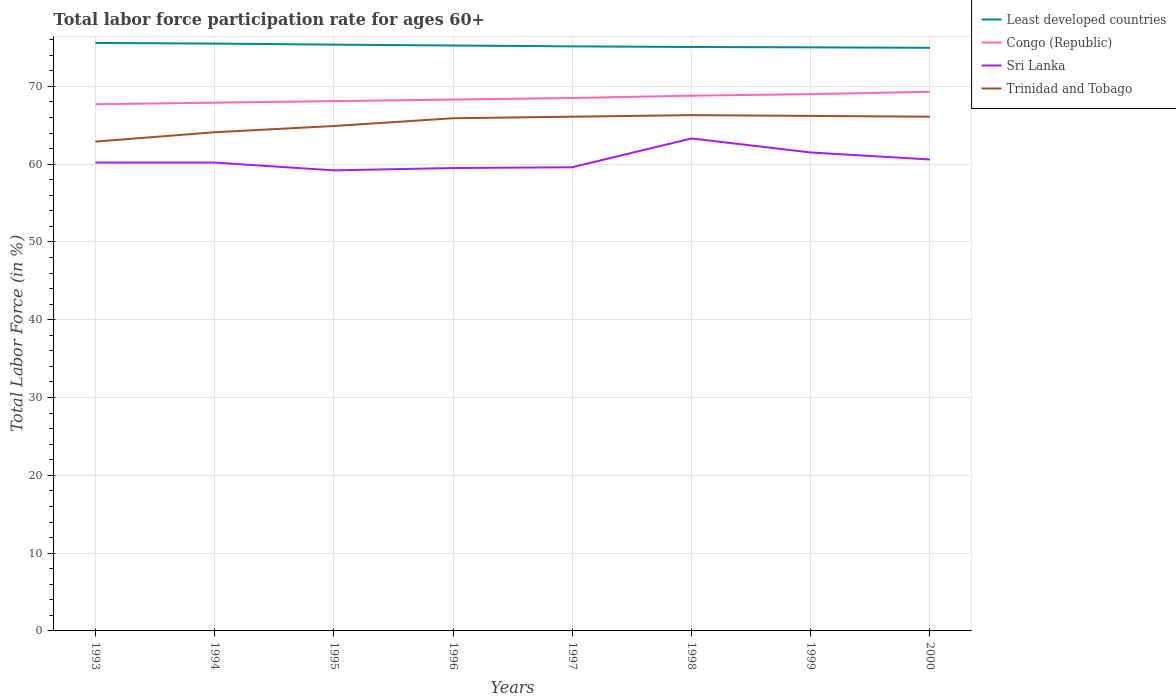How many different coloured lines are there?
Provide a succinct answer. 4. Does the line corresponding to Least developed countries intersect with the line corresponding to Sri Lanka?
Keep it short and to the point. No. Across all years, what is the maximum labor force participation rate in Least developed countries?
Provide a short and direct response. 74.95. In which year was the labor force participation rate in Sri Lanka maximum?
Provide a succinct answer. 1995. What is the total labor force participation rate in Least developed countries in the graph?
Ensure brevity in your answer.  0.11. What is the difference between the highest and the second highest labor force participation rate in Least developed countries?
Offer a terse response. 0.62. How many years are there in the graph?
Ensure brevity in your answer.  8. Are the values on the major ticks of Y-axis written in scientific E-notation?
Keep it short and to the point. No. Does the graph contain any zero values?
Your response must be concise. No. How many legend labels are there?
Provide a succinct answer. 4. What is the title of the graph?
Give a very brief answer. Total labor force participation rate for ages 60+. Does "Kiribati" appear as one of the legend labels in the graph?
Provide a succinct answer. No. What is the Total Labor Force (in %) in Least developed countries in 1993?
Keep it short and to the point. 75.58. What is the Total Labor Force (in %) of Congo (Republic) in 1993?
Your response must be concise. 67.7. What is the Total Labor Force (in %) of Sri Lanka in 1993?
Ensure brevity in your answer.  60.2. What is the Total Labor Force (in %) in Trinidad and Tobago in 1993?
Ensure brevity in your answer.  62.9. What is the Total Labor Force (in %) of Least developed countries in 1994?
Provide a short and direct response. 75.49. What is the Total Labor Force (in %) of Congo (Republic) in 1994?
Offer a terse response. 67.9. What is the Total Labor Force (in %) in Sri Lanka in 1994?
Make the answer very short. 60.2. What is the Total Labor Force (in %) in Trinidad and Tobago in 1994?
Your answer should be very brief. 64.1. What is the Total Labor Force (in %) in Least developed countries in 1995?
Keep it short and to the point. 75.36. What is the Total Labor Force (in %) of Congo (Republic) in 1995?
Make the answer very short. 68.1. What is the Total Labor Force (in %) of Sri Lanka in 1995?
Offer a very short reply. 59.2. What is the Total Labor Force (in %) of Trinidad and Tobago in 1995?
Give a very brief answer. 64.9. What is the Total Labor Force (in %) in Least developed countries in 1996?
Your answer should be compact. 75.25. What is the Total Labor Force (in %) of Congo (Republic) in 1996?
Provide a short and direct response. 68.3. What is the Total Labor Force (in %) of Sri Lanka in 1996?
Your answer should be compact. 59.5. What is the Total Labor Force (in %) in Trinidad and Tobago in 1996?
Make the answer very short. 65.9. What is the Total Labor Force (in %) of Least developed countries in 1997?
Your answer should be compact. 75.14. What is the Total Labor Force (in %) in Congo (Republic) in 1997?
Your answer should be very brief. 68.5. What is the Total Labor Force (in %) in Sri Lanka in 1997?
Provide a short and direct response. 59.6. What is the Total Labor Force (in %) in Trinidad and Tobago in 1997?
Your response must be concise. 66.1. What is the Total Labor Force (in %) of Least developed countries in 1998?
Your answer should be very brief. 75.06. What is the Total Labor Force (in %) of Congo (Republic) in 1998?
Provide a short and direct response. 68.8. What is the Total Labor Force (in %) in Sri Lanka in 1998?
Your answer should be compact. 63.3. What is the Total Labor Force (in %) of Trinidad and Tobago in 1998?
Your response must be concise. 66.3. What is the Total Labor Force (in %) in Least developed countries in 1999?
Keep it short and to the point. 75.02. What is the Total Labor Force (in %) of Sri Lanka in 1999?
Provide a succinct answer. 61.5. What is the Total Labor Force (in %) of Trinidad and Tobago in 1999?
Provide a short and direct response. 66.2. What is the Total Labor Force (in %) of Least developed countries in 2000?
Your answer should be compact. 74.95. What is the Total Labor Force (in %) of Congo (Republic) in 2000?
Provide a short and direct response. 69.3. What is the Total Labor Force (in %) of Sri Lanka in 2000?
Your answer should be compact. 60.6. What is the Total Labor Force (in %) of Trinidad and Tobago in 2000?
Provide a short and direct response. 66.1. Across all years, what is the maximum Total Labor Force (in %) in Least developed countries?
Provide a succinct answer. 75.58. Across all years, what is the maximum Total Labor Force (in %) in Congo (Republic)?
Provide a short and direct response. 69.3. Across all years, what is the maximum Total Labor Force (in %) in Sri Lanka?
Keep it short and to the point. 63.3. Across all years, what is the maximum Total Labor Force (in %) of Trinidad and Tobago?
Your response must be concise. 66.3. Across all years, what is the minimum Total Labor Force (in %) of Least developed countries?
Ensure brevity in your answer.  74.95. Across all years, what is the minimum Total Labor Force (in %) in Congo (Republic)?
Ensure brevity in your answer.  67.7. Across all years, what is the minimum Total Labor Force (in %) of Sri Lanka?
Your answer should be very brief. 59.2. Across all years, what is the minimum Total Labor Force (in %) in Trinidad and Tobago?
Your answer should be compact. 62.9. What is the total Total Labor Force (in %) of Least developed countries in the graph?
Offer a terse response. 601.85. What is the total Total Labor Force (in %) of Congo (Republic) in the graph?
Keep it short and to the point. 547.6. What is the total Total Labor Force (in %) in Sri Lanka in the graph?
Your response must be concise. 484.1. What is the total Total Labor Force (in %) in Trinidad and Tobago in the graph?
Offer a terse response. 522.5. What is the difference between the Total Labor Force (in %) in Least developed countries in 1993 and that in 1994?
Provide a short and direct response. 0.08. What is the difference between the Total Labor Force (in %) in Sri Lanka in 1993 and that in 1994?
Make the answer very short. 0. What is the difference between the Total Labor Force (in %) in Trinidad and Tobago in 1993 and that in 1994?
Give a very brief answer. -1.2. What is the difference between the Total Labor Force (in %) of Least developed countries in 1993 and that in 1995?
Provide a short and direct response. 0.22. What is the difference between the Total Labor Force (in %) in Congo (Republic) in 1993 and that in 1995?
Provide a short and direct response. -0.4. What is the difference between the Total Labor Force (in %) in Trinidad and Tobago in 1993 and that in 1995?
Your answer should be compact. -2. What is the difference between the Total Labor Force (in %) in Least developed countries in 1993 and that in 1996?
Your response must be concise. 0.33. What is the difference between the Total Labor Force (in %) of Least developed countries in 1993 and that in 1997?
Keep it short and to the point. 0.44. What is the difference between the Total Labor Force (in %) in Sri Lanka in 1993 and that in 1997?
Your response must be concise. 0.6. What is the difference between the Total Labor Force (in %) of Trinidad and Tobago in 1993 and that in 1997?
Your answer should be very brief. -3.2. What is the difference between the Total Labor Force (in %) of Least developed countries in 1993 and that in 1998?
Ensure brevity in your answer.  0.52. What is the difference between the Total Labor Force (in %) in Sri Lanka in 1993 and that in 1998?
Offer a terse response. -3.1. What is the difference between the Total Labor Force (in %) in Least developed countries in 1993 and that in 1999?
Keep it short and to the point. 0.56. What is the difference between the Total Labor Force (in %) of Congo (Republic) in 1993 and that in 1999?
Your response must be concise. -1.3. What is the difference between the Total Labor Force (in %) of Least developed countries in 1993 and that in 2000?
Keep it short and to the point. 0.62. What is the difference between the Total Labor Force (in %) in Sri Lanka in 1993 and that in 2000?
Your answer should be very brief. -0.4. What is the difference between the Total Labor Force (in %) in Least developed countries in 1994 and that in 1995?
Offer a very short reply. 0.13. What is the difference between the Total Labor Force (in %) in Congo (Republic) in 1994 and that in 1995?
Offer a very short reply. -0.2. What is the difference between the Total Labor Force (in %) in Trinidad and Tobago in 1994 and that in 1995?
Provide a succinct answer. -0.8. What is the difference between the Total Labor Force (in %) of Least developed countries in 1994 and that in 1996?
Offer a very short reply. 0.25. What is the difference between the Total Labor Force (in %) in Sri Lanka in 1994 and that in 1996?
Provide a succinct answer. 0.7. What is the difference between the Total Labor Force (in %) in Trinidad and Tobago in 1994 and that in 1996?
Give a very brief answer. -1.8. What is the difference between the Total Labor Force (in %) in Least developed countries in 1994 and that in 1997?
Offer a very short reply. 0.35. What is the difference between the Total Labor Force (in %) in Least developed countries in 1994 and that in 1998?
Ensure brevity in your answer.  0.44. What is the difference between the Total Labor Force (in %) of Congo (Republic) in 1994 and that in 1998?
Give a very brief answer. -0.9. What is the difference between the Total Labor Force (in %) of Sri Lanka in 1994 and that in 1998?
Offer a terse response. -3.1. What is the difference between the Total Labor Force (in %) of Trinidad and Tobago in 1994 and that in 1998?
Make the answer very short. -2.2. What is the difference between the Total Labor Force (in %) of Least developed countries in 1994 and that in 1999?
Offer a very short reply. 0.48. What is the difference between the Total Labor Force (in %) in Congo (Republic) in 1994 and that in 1999?
Offer a very short reply. -1.1. What is the difference between the Total Labor Force (in %) of Sri Lanka in 1994 and that in 1999?
Offer a terse response. -1.3. What is the difference between the Total Labor Force (in %) in Least developed countries in 1994 and that in 2000?
Ensure brevity in your answer.  0.54. What is the difference between the Total Labor Force (in %) in Sri Lanka in 1994 and that in 2000?
Keep it short and to the point. -0.4. What is the difference between the Total Labor Force (in %) in Trinidad and Tobago in 1994 and that in 2000?
Ensure brevity in your answer.  -2. What is the difference between the Total Labor Force (in %) of Least developed countries in 1995 and that in 1996?
Offer a very short reply. 0.11. What is the difference between the Total Labor Force (in %) of Least developed countries in 1995 and that in 1997?
Make the answer very short. 0.22. What is the difference between the Total Labor Force (in %) in Sri Lanka in 1995 and that in 1997?
Your response must be concise. -0.4. What is the difference between the Total Labor Force (in %) of Trinidad and Tobago in 1995 and that in 1997?
Make the answer very short. -1.2. What is the difference between the Total Labor Force (in %) in Least developed countries in 1995 and that in 1998?
Provide a short and direct response. 0.31. What is the difference between the Total Labor Force (in %) in Congo (Republic) in 1995 and that in 1998?
Your answer should be very brief. -0.7. What is the difference between the Total Labor Force (in %) in Sri Lanka in 1995 and that in 1998?
Give a very brief answer. -4.1. What is the difference between the Total Labor Force (in %) in Least developed countries in 1995 and that in 1999?
Ensure brevity in your answer.  0.35. What is the difference between the Total Labor Force (in %) in Sri Lanka in 1995 and that in 1999?
Your answer should be very brief. -2.3. What is the difference between the Total Labor Force (in %) of Least developed countries in 1995 and that in 2000?
Provide a short and direct response. 0.41. What is the difference between the Total Labor Force (in %) of Sri Lanka in 1995 and that in 2000?
Provide a short and direct response. -1.4. What is the difference between the Total Labor Force (in %) of Trinidad and Tobago in 1995 and that in 2000?
Give a very brief answer. -1.2. What is the difference between the Total Labor Force (in %) in Least developed countries in 1996 and that in 1997?
Keep it short and to the point. 0.11. What is the difference between the Total Labor Force (in %) of Sri Lanka in 1996 and that in 1997?
Your answer should be very brief. -0.1. What is the difference between the Total Labor Force (in %) in Trinidad and Tobago in 1996 and that in 1997?
Ensure brevity in your answer.  -0.2. What is the difference between the Total Labor Force (in %) of Least developed countries in 1996 and that in 1998?
Your answer should be compact. 0.19. What is the difference between the Total Labor Force (in %) in Trinidad and Tobago in 1996 and that in 1998?
Offer a terse response. -0.4. What is the difference between the Total Labor Force (in %) in Least developed countries in 1996 and that in 1999?
Offer a very short reply. 0.23. What is the difference between the Total Labor Force (in %) in Congo (Republic) in 1996 and that in 1999?
Your answer should be very brief. -0.7. What is the difference between the Total Labor Force (in %) of Sri Lanka in 1996 and that in 1999?
Offer a terse response. -2. What is the difference between the Total Labor Force (in %) of Least developed countries in 1996 and that in 2000?
Your response must be concise. 0.29. What is the difference between the Total Labor Force (in %) of Congo (Republic) in 1996 and that in 2000?
Provide a short and direct response. -1. What is the difference between the Total Labor Force (in %) in Trinidad and Tobago in 1996 and that in 2000?
Give a very brief answer. -0.2. What is the difference between the Total Labor Force (in %) in Least developed countries in 1997 and that in 1998?
Your answer should be compact. 0.08. What is the difference between the Total Labor Force (in %) of Sri Lanka in 1997 and that in 1998?
Give a very brief answer. -3.7. What is the difference between the Total Labor Force (in %) of Least developed countries in 1997 and that in 1999?
Offer a terse response. 0.12. What is the difference between the Total Labor Force (in %) in Congo (Republic) in 1997 and that in 1999?
Provide a short and direct response. -0.5. What is the difference between the Total Labor Force (in %) of Least developed countries in 1997 and that in 2000?
Provide a succinct answer. 0.19. What is the difference between the Total Labor Force (in %) of Congo (Republic) in 1997 and that in 2000?
Keep it short and to the point. -0.8. What is the difference between the Total Labor Force (in %) in Sri Lanka in 1997 and that in 2000?
Your answer should be compact. -1. What is the difference between the Total Labor Force (in %) of Trinidad and Tobago in 1997 and that in 2000?
Provide a short and direct response. 0. What is the difference between the Total Labor Force (in %) in Least developed countries in 1998 and that in 1999?
Give a very brief answer. 0.04. What is the difference between the Total Labor Force (in %) of Trinidad and Tobago in 1998 and that in 1999?
Ensure brevity in your answer.  0.1. What is the difference between the Total Labor Force (in %) of Least developed countries in 1998 and that in 2000?
Your response must be concise. 0.1. What is the difference between the Total Labor Force (in %) of Congo (Republic) in 1998 and that in 2000?
Your answer should be very brief. -0.5. What is the difference between the Total Labor Force (in %) in Least developed countries in 1999 and that in 2000?
Your response must be concise. 0.06. What is the difference between the Total Labor Force (in %) in Congo (Republic) in 1999 and that in 2000?
Ensure brevity in your answer.  -0.3. What is the difference between the Total Labor Force (in %) in Sri Lanka in 1999 and that in 2000?
Keep it short and to the point. 0.9. What is the difference between the Total Labor Force (in %) of Trinidad and Tobago in 1999 and that in 2000?
Offer a terse response. 0.1. What is the difference between the Total Labor Force (in %) of Least developed countries in 1993 and the Total Labor Force (in %) of Congo (Republic) in 1994?
Your answer should be very brief. 7.68. What is the difference between the Total Labor Force (in %) of Least developed countries in 1993 and the Total Labor Force (in %) of Sri Lanka in 1994?
Your response must be concise. 15.38. What is the difference between the Total Labor Force (in %) of Least developed countries in 1993 and the Total Labor Force (in %) of Trinidad and Tobago in 1994?
Ensure brevity in your answer.  11.48. What is the difference between the Total Labor Force (in %) in Congo (Republic) in 1993 and the Total Labor Force (in %) in Trinidad and Tobago in 1994?
Your answer should be compact. 3.6. What is the difference between the Total Labor Force (in %) of Least developed countries in 1993 and the Total Labor Force (in %) of Congo (Republic) in 1995?
Your answer should be very brief. 7.48. What is the difference between the Total Labor Force (in %) in Least developed countries in 1993 and the Total Labor Force (in %) in Sri Lanka in 1995?
Provide a succinct answer. 16.38. What is the difference between the Total Labor Force (in %) of Least developed countries in 1993 and the Total Labor Force (in %) of Trinidad and Tobago in 1995?
Your answer should be very brief. 10.68. What is the difference between the Total Labor Force (in %) in Congo (Republic) in 1993 and the Total Labor Force (in %) in Sri Lanka in 1995?
Offer a very short reply. 8.5. What is the difference between the Total Labor Force (in %) of Sri Lanka in 1993 and the Total Labor Force (in %) of Trinidad and Tobago in 1995?
Ensure brevity in your answer.  -4.7. What is the difference between the Total Labor Force (in %) in Least developed countries in 1993 and the Total Labor Force (in %) in Congo (Republic) in 1996?
Your answer should be very brief. 7.28. What is the difference between the Total Labor Force (in %) in Least developed countries in 1993 and the Total Labor Force (in %) in Sri Lanka in 1996?
Your answer should be very brief. 16.08. What is the difference between the Total Labor Force (in %) in Least developed countries in 1993 and the Total Labor Force (in %) in Trinidad and Tobago in 1996?
Ensure brevity in your answer.  9.68. What is the difference between the Total Labor Force (in %) of Congo (Republic) in 1993 and the Total Labor Force (in %) of Sri Lanka in 1996?
Keep it short and to the point. 8.2. What is the difference between the Total Labor Force (in %) of Sri Lanka in 1993 and the Total Labor Force (in %) of Trinidad and Tobago in 1996?
Keep it short and to the point. -5.7. What is the difference between the Total Labor Force (in %) in Least developed countries in 1993 and the Total Labor Force (in %) in Congo (Republic) in 1997?
Offer a terse response. 7.08. What is the difference between the Total Labor Force (in %) in Least developed countries in 1993 and the Total Labor Force (in %) in Sri Lanka in 1997?
Your answer should be very brief. 15.98. What is the difference between the Total Labor Force (in %) of Least developed countries in 1993 and the Total Labor Force (in %) of Trinidad and Tobago in 1997?
Keep it short and to the point. 9.48. What is the difference between the Total Labor Force (in %) in Congo (Republic) in 1993 and the Total Labor Force (in %) in Trinidad and Tobago in 1997?
Ensure brevity in your answer.  1.6. What is the difference between the Total Labor Force (in %) of Sri Lanka in 1993 and the Total Labor Force (in %) of Trinidad and Tobago in 1997?
Provide a short and direct response. -5.9. What is the difference between the Total Labor Force (in %) in Least developed countries in 1993 and the Total Labor Force (in %) in Congo (Republic) in 1998?
Provide a succinct answer. 6.78. What is the difference between the Total Labor Force (in %) of Least developed countries in 1993 and the Total Labor Force (in %) of Sri Lanka in 1998?
Keep it short and to the point. 12.28. What is the difference between the Total Labor Force (in %) of Least developed countries in 1993 and the Total Labor Force (in %) of Trinidad and Tobago in 1998?
Provide a short and direct response. 9.28. What is the difference between the Total Labor Force (in %) in Congo (Republic) in 1993 and the Total Labor Force (in %) in Sri Lanka in 1998?
Provide a succinct answer. 4.4. What is the difference between the Total Labor Force (in %) of Least developed countries in 1993 and the Total Labor Force (in %) of Congo (Republic) in 1999?
Make the answer very short. 6.58. What is the difference between the Total Labor Force (in %) of Least developed countries in 1993 and the Total Labor Force (in %) of Sri Lanka in 1999?
Provide a short and direct response. 14.08. What is the difference between the Total Labor Force (in %) in Least developed countries in 1993 and the Total Labor Force (in %) in Trinidad and Tobago in 1999?
Give a very brief answer. 9.38. What is the difference between the Total Labor Force (in %) of Sri Lanka in 1993 and the Total Labor Force (in %) of Trinidad and Tobago in 1999?
Your answer should be very brief. -6. What is the difference between the Total Labor Force (in %) in Least developed countries in 1993 and the Total Labor Force (in %) in Congo (Republic) in 2000?
Give a very brief answer. 6.28. What is the difference between the Total Labor Force (in %) of Least developed countries in 1993 and the Total Labor Force (in %) of Sri Lanka in 2000?
Give a very brief answer. 14.98. What is the difference between the Total Labor Force (in %) in Least developed countries in 1993 and the Total Labor Force (in %) in Trinidad and Tobago in 2000?
Your answer should be compact. 9.48. What is the difference between the Total Labor Force (in %) in Sri Lanka in 1993 and the Total Labor Force (in %) in Trinidad and Tobago in 2000?
Make the answer very short. -5.9. What is the difference between the Total Labor Force (in %) of Least developed countries in 1994 and the Total Labor Force (in %) of Congo (Republic) in 1995?
Provide a short and direct response. 7.39. What is the difference between the Total Labor Force (in %) in Least developed countries in 1994 and the Total Labor Force (in %) in Sri Lanka in 1995?
Offer a very short reply. 16.29. What is the difference between the Total Labor Force (in %) of Least developed countries in 1994 and the Total Labor Force (in %) of Trinidad and Tobago in 1995?
Provide a short and direct response. 10.59. What is the difference between the Total Labor Force (in %) of Congo (Republic) in 1994 and the Total Labor Force (in %) of Sri Lanka in 1995?
Provide a short and direct response. 8.7. What is the difference between the Total Labor Force (in %) of Least developed countries in 1994 and the Total Labor Force (in %) of Congo (Republic) in 1996?
Give a very brief answer. 7.19. What is the difference between the Total Labor Force (in %) of Least developed countries in 1994 and the Total Labor Force (in %) of Sri Lanka in 1996?
Ensure brevity in your answer.  15.99. What is the difference between the Total Labor Force (in %) of Least developed countries in 1994 and the Total Labor Force (in %) of Trinidad and Tobago in 1996?
Your answer should be very brief. 9.59. What is the difference between the Total Labor Force (in %) in Congo (Republic) in 1994 and the Total Labor Force (in %) in Trinidad and Tobago in 1996?
Your answer should be compact. 2. What is the difference between the Total Labor Force (in %) in Sri Lanka in 1994 and the Total Labor Force (in %) in Trinidad and Tobago in 1996?
Offer a very short reply. -5.7. What is the difference between the Total Labor Force (in %) of Least developed countries in 1994 and the Total Labor Force (in %) of Congo (Republic) in 1997?
Your answer should be very brief. 6.99. What is the difference between the Total Labor Force (in %) in Least developed countries in 1994 and the Total Labor Force (in %) in Sri Lanka in 1997?
Provide a short and direct response. 15.89. What is the difference between the Total Labor Force (in %) in Least developed countries in 1994 and the Total Labor Force (in %) in Trinidad and Tobago in 1997?
Offer a very short reply. 9.39. What is the difference between the Total Labor Force (in %) of Congo (Republic) in 1994 and the Total Labor Force (in %) of Sri Lanka in 1997?
Offer a very short reply. 8.3. What is the difference between the Total Labor Force (in %) in Congo (Republic) in 1994 and the Total Labor Force (in %) in Trinidad and Tobago in 1997?
Offer a terse response. 1.8. What is the difference between the Total Labor Force (in %) of Least developed countries in 1994 and the Total Labor Force (in %) of Congo (Republic) in 1998?
Give a very brief answer. 6.69. What is the difference between the Total Labor Force (in %) of Least developed countries in 1994 and the Total Labor Force (in %) of Sri Lanka in 1998?
Your answer should be very brief. 12.19. What is the difference between the Total Labor Force (in %) of Least developed countries in 1994 and the Total Labor Force (in %) of Trinidad and Tobago in 1998?
Your response must be concise. 9.19. What is the difference between the Total Labor Force (in %) of Congo (Republic) in 1994 and the Total Labor Force (in %) of Trinidad and Tobago in 1998?
Ensure brevity in your answer.  1.6. What is the difference between the Total Labor Force (in %) of Sri Lanka in 1994 and the Total Labor Force (in %) of Trinidad and Tobago in 1998?
Make the answer very short. -6.1. What is the difference between the Total Labor Force (in %) in Least developed countries in 1994 and the Total Labor Force (in %) in Congo (Republic) in 1999?
Offer a terse response. 6.49. What is the difference between the Total Labor Force (in %) in Least developed countries in 1994 and the Total Labor Force (in %) in Sri Lanka in 1999?
Offer a very short reply. 13.99. What is the difference between the Total Labor Force (in %) of Least developed countries in 1994 and the Total Labor Force (in %) of Trinidad and Tobago in 1999?
Your response must be concise. 9.29. What is the difference between the Total Labor Force (in %) in Congo (Republic) in 1994 and the Total Labor Force (in %) in Sri Lanka in 1999?
Give a very brief answer. 6.4. What is the difference between the Total Labor Force (in %) in Congo (Republic) in 1994 and the Total Labor Force (in %) in Trinidad and Tobago in 1999?
Give a very brief answer. 1.7. What is the difference between the Total Labor Force (in %) of Sri Lanka in 1994 and the Total Labor Force (in %) of Trinidad and Tobago in 1999?
Your answer should be compact. -6. What is the difference between the Total Labor Force (in %) of Least developed countries in 1994 and the Total Labor Force (in %) of Congo (Republic) in 2000?
Make the answer very short. 6.19. What is the difference between the Total Labor Force (in %) of Least developed countries in 1994 and the Total Labor Force (in %) of Sri Lanka in 2000?
Your response must be concise. 14.89. What is the difference between the Total Labor Force (in %) of Least developed countries in 1994 and the Total Labor Force (in %) of Trinidad and Tobago in 2000?
Ensure brevity in your answer.  9.39. What is the difference between the Total Labor Force (in %) of Sri Lanka in 1994 and the Total Labor Force (in %) of Trinidad and Tobago in 2000?
Give a very brief answer. -5.9. What is the difference between the Total Labor Force (in %) in Least developed countries in 1995 and the Total Labor Force (in %) in Congo (Republic) in 1996?
Provide a short and direct response. 7.06. What is the difference between the Total Labor Force (in %) in Least developed countries in 1995 and the Total Labor Force (in %) in Sri Lanka in 1996?
Offer a terse response. 15.86. What is the difference between the Total Labor Force (in %) of Least developed countries in 1995 and the Total Labor Force (in %) of Trinidad and Tobago in 1996?
Offer a very short reply. 9.46. What is the difference between the Total Labor Force (in %) in Congo (Republic) in 1995 and the Total Labor Force (in %) in Sri Lanka in 1996?
Offer a terse response. 8.6. What is the difference between the Total Labor Force (in %) of Sri Lanka in 1995 and the Total Labor Force (in %) of Trinidad and Tobago in 1996?
Provide a short and direct response. -6.7. What is the difference between the Total Labor Force (in %) of Least developed countries in 1995 and the Total Labor Force (in %) of Congo (Republic) in 1997?
Your answer should be compact. 6.86. What is the difference between the Total Labor Force (in %) of Least developed countries in 1995 and the Total Labor Force (in %) of Sri Lanka in 1997?
Make the answer very short. 15.76. What is the difference between the Total Labor Force (in %) in Least developed countries in 1995 and the Total Labor Force (in %) in Trinidad and Tobago in 1997?
Ensure brevity in your answer.  9.26. What is the difference between the Total Labor Force (in %) in Congo (Republic) in 1995 and the Total Labor Force (in %) in Sri Lanka in 1997?
Give a very brief answer. 8.5. What is the difference between the Total Labor Force (in %) of Least developed countries in 1995 and the Total Labor Force (in %) of Congo (Republic) in 1998?
Your answer should be compact. 6.56. What is the difference between the Total Labor Force (in %) in Least developed countries in 1995 and the Total Labor Force (in %) in Sri Lanka in 1998?
Provide a succinct answer. 12.06. What is the difference between the Total Labor Force (in %) in Least developed countries in 1995 and the Total Labor Force (in %) in Trinidad and Tobago in 1998?
Your answer should be very brief. 9.06. What is the difference between the Total Labor Force (in %) in Least developed countries in 1995 and the Total Labor Force (in %) in Congo (Republic) in 1999?
Offer a terse response. 6.36. What is the difference between the Total Labor Force (in %) of Least developed countries in 1995 and the Total Labor Force (in %) of Sri Lanka in 1999?
Provide a short and direct response. 13.86. What is the difference between the Total Labor Force (in %) in Least developed countries in 1995 and the Total Labor Force (in %) in Trinidad and Tobago in 1999?
Make the answer very short. 9.16. What is the difference between the Total Labor Force (in %) of Congo (Republic) in 1995 and the Total Labor Force (in %) of Sri Lanka in 1999?
Offer a very short reply. 6.6. What is the difference between the Total Labor Force (in %) in Congo (Republic) in 1995 and the Total Labor Force (in %) in Trinidad and Tobago in 1999?
Your answer should be very brief. 1.9. What is the difference between the Total Labor Force (in %) of Least developed countries in 1995 and the Total Labor Force (in %) of Congo (Republic) in 2000?
Provide a short and direct response. 6.06. What is the difference between the Total Labor Force (in %) of Least developed countries in 1995 and the Total Labor Force (in %) of Sri Lanka in 2000?
Provide a short and direct response. 14.76. What is the difference between the Total Labor Force (in %) in Least developed countries in 1995 and the Total Labor Force (in %) in Trinidad and Tobago in 2000?
Offer a terse response. 9.26. What is the difference between the Total Labor Force (in %) of Congo (Republic) in 1995 and the Total Labor Force (in %) of Sri Lanka in 2000?
Your answer should be compact. 7.5. What is the difference between the Total Labor Force (in %) in Least developed countries in 1996 and the Total Labor Force (in %) in Congo (Republic) in 1997?
Give a very brief answer. 6.75. What is the difference between the Total Labor Force (in %) in Least developed countries in 1996 and the Total Labor Force (in %) in Sri Lanka in 1997?
Give a very brief answer. 15.65. What is the difference between the Total Labor Force (in %) in Least developed countries in 1996 and the Total Labor Force (in %) in Trinidad and Tobago in 1997?
Offer a terse response. 9.15. What is the difference between the Total Labor Force (in %) in Congo (Republic) in 1996 and the Total Labor Force (in %) in Sri Lanka in 1997?
Your answer should be compact. 8.7. What is the difference between the Total Labor Force (in %) of Least developed countries in 1996 and the Total Labor Force (in %) of Congo (Republic) in 1998?
Offer a terse response. 6.45. What is the difference between the Total Labor Force (in %) of Least developed countries in 1996 and the Total Labor Force (in %) of Sri Lanka in 1998?
Your answer should be very brief. 11.95. What is the difference between the Total Labor Force (in %) of Least developed countries in 1996 and the Total Labor Force (in %) of Trinidad and Tobago in 1998?
Your answer should be compact. 8.95. What is the difference between the Total Labor Force (in %) of Congo (Republic) in 1996 and the Total Labor Force (in %) of Trinidad and Tobago in 1998?
Make the answer very short. 2. What is the difference between the Total Labor Force (in %) in Sri Lanka in 1996 and the Total Labor Force (in %) in Trinidad and Tobago in 1998?
Make the answer very short. -6.8. What is the difference between the Total Labor Force (in %) in Least developed countries in 1996 and the Total Labor Force (in %) in Congo (Republic) in 1999?
Give a very brief answer. 6.25. What is the difference between the Total Labor Force (in %) of Least developed countries in 1996 and the Total Labor Force (in %) of Sri Lanka in 1999?
Offer a very short reply. 13.75. What is the difference between the Total Labor Force (in %) of Least developed countries in 1996 and the Total Labor Force (in %) of Trinidad and Tobago in 1999?
Your answer should be compact. 9.05. What is the difference between the Total Labor Force (in %) in Sri Lanka in 1996 and the Total Labor Force (in %) in Trinidad and Tobago in 1999?
Your answer should be compact. -6.7. What is the difference between the Total Labor Force (in %) of Least developed countries in 1996 and the Total Labor Force (in %) of Congo (Republic) in 2000?
Make the answer very short. 5.95. What is the difference between the Total Labor Force (in %) of Least developed countries in 1996 and the Total Labor Force (in %) of Sri Lanka in 2000?
Keep it short and to the point. 14.65. What is the difference between the Total Labor Force (in %) in Least developed countries in 1996 and the Total Labor Force (in %) in Trinidad and Tobago in 2000?
Your response must be concise. 9.15. What is the difference between the Total Labor Force (in %) in Least developed countries in 1997 and the Total Labor Force (in %) in Congo (Republic) in 1998?
Your answer should be very brief. 6.34. What is the difference between the Total Labor Force (in %) of Least developed countries in 1997 and the Total Labor Force (in %) of Sri Lanka in 1998?
Give a very brief answer. 11.84. What is the difference between the Total Labor Force (in %) in Least developed countries in 1997 and the Total Labor Force (in %) in Trinidad and Tobago in 1998?
Your answer should be very brief. 8.84. What is the difference between the Total Labor Force (in %) in Congo (Republic) in 1997 and the Total Labor Force (in %) in Sri Lanka in 1998?
Your response must be concise. 5.2. What is the difference between the Total Labor Force (in %) of Sri Lanka in 1997 and the Total Labor Force (in %) of Trinidad and Tobago in 1998?
Make the answer very short. -6.7. What is the difference between the Total Labor Force (in %) of Least developed countries in 1997 and the Total Labor Force (in %) of Congo (Republic) in 1999?
Give a very brief answer. 6.14. What is the difference between the Total Labor Force (in %) in Least developed countries in 1997 and the Total Labor Force (in %) in Sri Lanka in 1999?
Make the answer very short. 13.64. What is the difference between the Total Labor Force (in %) in Least developed countries in 1997 and the Total Labor Force (in %) in Trinidad and Tobago in 1999?
Offer a very short reply. 8.94. What is the difference between the Total Labor Force (in %) in Congo (Republic) in 1997 and the Total Labor Force (in %) in Sri Lanka in 1999?
Keep it short and to the point. 7. What is the difference between the Total Labor Force (in %) in Sri Lanka in 1997 and the Total Labor Force (in %) in Trinidad and Tobago in 1999?
Provide a short and direct response. -6.6. What is the difference between the Total Labor Force (in %) in Least developed countries in 1997 and the Total Labor Force (in %) in Congo (Republic) in 2000?
Ensure brevity in your answer.  5.84. What is the difference between the Total Labor Force (in %) in Least developed countries in 1997 and the Total Labor Force (in %) in Sri Lanka in 2000?
Make the answer very short. 14.54. What is the difference between the Total Labor Force (in %) in Least developed countries in 1997 and the Total Labor Force (in %) in Trinidad and Tobago in 2000?
Offer a terse response. 9.04. What is the difference between the Total Labor Force (in %) of Congo (Republic) in 1997 and the Total Labor Force (in %) of Sri Lanka in 2000?
Offer a terse response. 7.9. What is the difference between the Total Labor Force (in %) in Sri Lanka in 1997 and the Total Labor Force (in %) in Trinidad and Tobago in 2000?
Offer a very short reply. -6.5. What is the difference between the Total Labor Force (in %) in Least developed countries in 1998 and the Total Labor Force (in %) in Congo (Republic) in 1999?
Offer a terse response. 6.06. What is the difference between the Total Labor Force (in %) of Least developed countries in 1998 and the Total Labor Force (in %) of Sri Lanka in 1999?
Your answer should be very brief. 13.56. What is the difference between the Total Labor Force (in %) in Least developed countries in 1998 and the Total Labor Force (in %) in Trinidad and Tobago in 1999?
Ensure brevity in your answer.  8.86. What is the difference between the Total Labor Force (in %) of Congo (Republic) in 1998 and the Total Labor Force (in %) of Trinidad and Tobago in 1999?
Provide a short and direct response. 2.6. What is the difference between the Total Labor Force (in %) in Sri Lanka in 1998 and the Total Labor Force (in %) in Trinidad and Tobago in 1999?
Make the answer very short. -2.9. What is the difference between the Total Labor Force (in %) of Least developed countries in 1998 and the Total Labor Force (in %) of Congo (Republic) in 2000?
Offer a terse response. 5.76. What is the difference between the Total Labor Force (in %) in Least developed countries in 1998 and the Total Labor Force (in %) in Sri Lanka in 2000?
Provide a succinct answer. 14.46. What is the difference between the Total Labor Force (in %) in Least developed countries in 1998 and the Total Labor Force (in %) in Trinidad and Tobago in 2000?
Keep it short and to the point. 8.96. What is the difference between the Total Labor Force (in %) in Congo (Republic) in 1998 and the Total Labor Force (in %) in Sri Lanka in 2000?
Make the answer very short. 8.2. What is the difference between the Total Labor Force (in %) of Congo (Republic) in 1998 and the Total Labor Force (in %) of Trinidad and Tobago in 2000?
Provide a succinct answer. 2.7. What is the difference between the Total Labor Force (in %) of Least developed countries in 1999 and the Total Labor Force (in %) of Congo (Republic) in 2000?
Offer a terse response. 5.72. What is the difference between the Total Labor Force (in %) of Least developed countries in 1999 and the Total Labor Force (in %) of Sri Lanka in 2000?
Keep it short and to the point. 14.42. What is the difference between the Total Labor Force (in %) in Least developed countries in 1999 and the Total Labor Force (in %) in Trinidad and Tobago in 2000?
Keep it short and to the point. 8.92. What is the difference between the Total Labor Force (in %) of Congo (Republic) in 1999 and the Total Labor Force (in %) of Sri Lanka in 2000?
Your answer should be very brief. 8.4. What is the average Total Labor Force (in %) of Least developed countries per year?
Your answer should be compact. 75.23. What is the average Total Labor Force (in %) of Congo (Republic) per year?
Make the answer very short. 68.45. What is the average Total Labor Force (in %) in Sri Lanka per year?
Offer a very short reply. 60.51. What is the average Total Labor Force (in %) of Trinidad and Tobago per year?
Ensure brevity in your answer.  65.31. In the year 1993, what is the difference between the Total Labor Force (in %) of Least developed countries and Total Labor Force (in %) of Congo (Republic)?
Offer a terse response. 7.88. In the year 1993, what is the difference between the Total Labor Force (in %) in Least developed countries and Total Labor Force (in %) in Sri Lanka?
Offer a very short reply. 15.38. In the year 1993, what is the difference between the Total Labor Force (in %) of Least developed countries and Total Labor Force (in %) of Trinidad and Tobago?
Ensure brevity in your answer.  12.68. In the year 1993, what is the difference between the Total Labor Force (in %) in Congo (Republic) and Total Labor Force (in %) in Sri Lanka?
Offer a very short reply. 7.5. In the year 1993, what is the difference between the Total Labor Force (in %) of Congo (Republic) and Total Labor Force (in %) of Trinidad and Tobago?
Offer a terse response. 4.8. In the year 1993, what is the difference between the Total Labor Force (in %) of Sri Lanka and Total Labor Force (in %) of Trinidad and Tobago?
Make the answer very short. -2.7. In the year 1994, what is the difference between the Total Labor Force (in %) in Least developed countries and Total Labor Force (in %) in Congo (Republic)?
Keep it short and to the point. 7.59. In the year 1994, what is the difference between the Total Labor Force (in %) in Least developed countries and Total Labor Force (in %) in Sri Lanka?
Your answer should be compact. 15.29. In the year 1994, what is the difference between the Total Labor Force (in %) in Least developed countries and Total Labor Force (in %) in Trinidad and Tobago?
Offer a terse response. 11.39. In the year 1994, what is the difference between the Total Labor Force (in %) in Congo (Republic) and Total Labor Force (in %) in Sri Lanka?
Your answer should be very brief. 7.7. In the year 1994, what is the difference between the Total Labor Force (in %) of Congo (Republic) and Total Labor Force (in %) of Trinidad and Tobago?
Ensure brevity in your answer.  3.8. In the year 1994, what is the difference between the Total Labor Force (in %) in Sri Lanka and Total Labor Force (in %) in Trinidad and Tobago?
Your answer should be very brief. -3.9. In the year 1995, what is the difference between the Total Labor Force (in %) in Least developed countries and Total Labor Force (in %) in Congo (Republic)?
Your answer should be very brief. 7.26. In the year 1995, what is the difference between the Total Labor Force (in %) of Least developed countries and Total Labor Force (in %) of Sri Lanka?
Offer a very short reply. 16.16. In the year 1995, what is the difference between the Total Labor Force (in %) in Least developed countries and Total Labor Force (in %) in Trinidad and Tobago?
Your answer should be compact. 10.46. In the year 1995, what is the difference between the Total Labor Force (in %) in Congo (Republic) and Total Labor Force (in %) in Trinidad and Tobago?
Give a very brief answer. 3.2. In the year 1996, what is the difference between the Total Labor Force (in %) of Least developed countries and Total Labor Force (in %) of Congo (Republic)?
Provide a short and direct response. 6.95. In the year 1996, what is the difference between the Total Labor Force (in %) of Least developed countries and Total Labor Force (in %) of Sri Lanka?
Provide a succinct answer. 15.75. In the year 1996, what is the difference between the Total Labor Force (in %) of Least developed countries and Total Labor Force (in %) of Trinidad and Tobago?
Provide a succinct answer. 9.35. In the year 1996, what is the difference between the Total Labor Force (in %) in Congo (Republic) and Total Labor Force (in %) in Sri Lanka?
Give a very brief answer. 8.8. In the year 1996, what is the difference between the Total Labor Force (in %) of Congo (Republic) and Total Labor Force (in %) of Trinidad and Tobago?
Keep it short and to the point. 2.4. In the year 1996, what is the difference between the Total Labor Force (in %) of Sri Lanka and Total Labor Force (in %) of Trinidad and Tobago?
Your answer should be compact. -6.4. In the year 1997, what is the difference between the Total Labor Force (in %) of Least developed countries and Total Labor Force (in %) of Congo (Republic)?
Provide a short and direct response. 6.64. In the year 1997, what is the difference between the Total Labor Force (in %) in Least developed countries and Total Labor Force (in %) in Sri Lanka?
Your response must be concise. 15.54. In the year 1997, what is the difference between the Total Labor Force (in %) of Least developed countries and Total Labor Force (in %) of Trinidad and Tobago?
Provide a succinct answer. 9.04. In the year 1998, what is the difference between the Total Labor Force (in %) of Least developed countries and Total Labor Force (in %) of Congo (Republic)?
Provide a succinct answer. 6.26. In the year 1998, what is the difference between the Total Labor Force (in %) of Least developed countries and Total Labor Force (in %) of Sri Lanka?
Provide a short and direct response. 11.76. In the year 1998, what is the difference between the Total Labor Force (in %) in Least developed countries and Total Labor Force (in %) in Trinidad and Tobago?
Offer a terse response. 8.76. In the year 1998, what is the difference between the Total Labor Force (in %) of Congo (Republic) and Total Labor Force (in %) of Trinidad and Tobago?
Provide a succinct answer. 2.5. In the year 1998, what is the difference between the Total Labor Force (in %) in Sri Lanka and Total Labor Force (in %) in Trinidad and Tobago?
Keep it short and to the point. -3. In the year 1999, what is the difference between the Total Labor Force (in %) of Least developed countries and Total Labor Force (in %) of Congo (Republic)?
Offer a very short reply. 6.02. In the year 1999, what is the difference between the Total Labor Force (in %) in Least developed countries and Total Labor Force (in %) in Sri Lanka?
Provide a succinct answer. 13.52. In the year 1999, what is the difference between the Total Labor Force (in %) of Least developed countries and Total Labor Force (in %) of Trinidad and Tobago?
Provide a short and direct response. 8.82. In the year 1999, what is the difference between the Total Labor Force (in %) of Congo (Republic) and Total Labor Force (in %) of Trinidad and Tobago?
Provide a succinct answer. 2.8. In the year 2000, what is the difference between the Total Labor Force (in %) in Least developed countries and Total Labor Force (in %) in Congo (Republic)?
Offer a terse response. 5.65. In the year 2000, what is the difference between the Total Labor Force (in %) of Least developed countries and Total Labor Force (in %) of Sri Lanka?
Offer a terse response. 14.35. In the year 2000, what is the difference between the Total Labor Force (in %) in Least developed countries and Total Labor Force (in %) in Trinidad and Tobago?
Provide a succinct answer. 8.85. In the year 2000, what is the difference between the Total Labor Force (in %) of Congo (Republic) and Total Labor Force (in %) of Sri Lanka?
Your answer should be very brief. 8.7. In the year 2000, what is the difference between the Total Labor Force (in %) in Congo (Republic) and Total Labor Force (in %) in Trinidad and Tobago?
Make the answer very short. 3.2. What is the ratio of the Total Labor Force (in %) in Congo (Republic) in 1993 to that in 1994?
Offer a very short reply. 1. What is the ratio of the Total Labor Force (in %) in Trinidad and Tobago in 1993 to that in 1994?
Your response must be concise. 0.98. What is the ratio of the Total Labor Force (in %) of Least developed countries in 1993 to that in 1995?
Your answer should be compact. 1. What is the ratio of the Total Labor Force (in %) in Congo (Republic) in 1993 to that in 1995?
Make the answer very short. 0.99. What is the ratio of the Total Labor Force (in %) of Sri Lanka in 1993 to that in 1995?
Your answer should be very brief. 1.02. What is the ratio of the Total Labor Force (in %) in Trinidad and Tobago in 1993 to that in 1995?
Ensure brevity in your answer.  0.97. What is the ratio of the Total Labor Force (in %) of Least developed countries in 1993 to that in 1996?
Your answer should be compact. 1. What is the ratio of the Total Labor Force (in %) of Sri Lanka in 1993 to that in 1996?
Keep it short and to the point. 1.01. What is the ratio of the Total Labor Force (in %) in Trinidad and Tobago in 1993 to that in 1996?
Provide a succinct answer. 0.95. What is the ratio of the Total Labor Force (in %) of Congo (Republic) in 1993 to that in 1997?
Provide a succinct answer. 0.99. What is the ratio of the Total Labor Force (in %) of Trinidad and Tobago in 1993 to that in 1997?
Ensure brevity in your answer.  0.95. What is the ratio of the Total Labor Force (in %) in Least developed countries in 1993 to that in 1998?
Ensure brevity in your answer.  1.01. What is the ratio of the Total Labor Force (in %) of Sri Lanka in 1993 to that in 1998?
Offer a terse response. 0.95. What is the ratio of the Total Labor Force (in %) in Trinidad and Tobago in 1993 to that in 1998?
Make the answer very short. 0.95. What is the ratio of the Total Labor Force (in %) of Least developed countries in 1993 to that in 1999?
Keep it short and to the point. 1.01. What is the ratio of the Total Labor Force (in %) in Congo (Republic) in 1993 to that in 1999?
Keep it short and to the point. 0.98. What is the ratio of the Total Labor Force (in %) of Sri Lanka in 1993 to that in 1999?
Your answer should be very brief. 0.98. What is the ratio of the Total Labor Force (in %) of Trinidad and Tobago in 1993 to that in 1999?
Offer a terse response. 0.95. What is the ratio of the Total Labor Force (in %) of Least developed countries in 1993 to that in 2000?
Your response must be concise. 1.01. What is the ratio of the Total Labor Force (in %) of Congo (Republic) in 1993 to that in 2000?
Your response must be concise. 0.98. What is the ratio of the Total Labor Force (in %) in Sri Lanka in 1993 to that in 2000?
Provide a short and direct response. 0.99. What is the ratio of the Total Labor Force (in %) in Trinidad and Tobago in 1993 to that in 2000?
Offer a terse response. 0.95. What is the ratio of the Total Labor Force (in %) in Congo (Republic) in 1994 to that in 1995?
Ensure brevity in your answer.  1. What is the ratio of the Total Labor Force (in %) of Sri Lanka in 1994 to that in 1995?
Make the answer very short. 1.02. What is the ratio of the Total Labor Force (in %) of Trinidad and Tobago in 1994 to that in 1995?
Your response must be concise. 0.99. What is the ratio of the Total Labor Force (in %) of Sri Lanka in 1994 to that in 1996?
Keep it short and to the point. 1.01. What is the ratio of the Total Labor Force (in %) of Trinidad and Tobago in 1994 to that in 1996?
Your response must be concise. 0.97. What is the ratio of the Total Labor Force (in %) of Congo (Republic) in 1994 to that in 1997?
Make the answer very short. 0.99. What is the ratio of the Total Labor Force (in %) of Trinidad and Tobago in 1994 to that in 1997?
Provide a short and direct response. 0.97. What is the ratio of the Total Labor Force (in %) in Least developed countries in 1994 to that in 1998?
Your response must be concise. 1.01. What is the ratio of the Total Labor Force (in %) of Congo (Republic) in 1994 to that in 1998?
Give a very brief answer. 0.99. What is the ratio of the Total Labor Force (in %) in Sri Lanka in 1994 to that in 1998?
Make the answer very short. 0.95. What is the ratio of the Total Labor Force (in %) of Trinidad and Tobago in 1994 to that in 1998?
Offer a terse response. 0.97. What is the ratio of the Total Labor Force (in %) of Least developed countries in 1994 to that in 1999?
Provide a short and direct response. 1.01. What is the ratio of the Total Labor Force (in %) of Congo (Republic) in 1994 to that in 1999?
Offer a terse response. 0.98. What is the ratio of the Total Labor Force (in %) of Sri Lanka in 1994 to that in 1999?
Provide a short and direct response. 0.98. What is the ratio of the Total Labor Force (in %) in Trinidad and Tobago in 1994 to that in 1999?
Offer a terse response. 0.97. What is the ratio of the Total Labor Force (in %) of Congo (Republic) in 1994 to that in 2000?
Offer a very short reply. 0.98. What is the ratio of the Total Labor Force (in %) in Trinidad and Tobago in 1994 to that in 2000?
Give a very brief answer. 0.97. What is the ratio of the Total Labor Force (in %) of Congo (Republic) in 1995 to that in 1996?
Your response must be concise. 1. What is the ratio of the Total Labor Force (in %) of Trinidad and Tobago in 1995 to that in 1996?
Offer a very short reply. 0.98. What is the ratio of the Total Labor Force (in %) of Trinidad and Tobago in 1995 to that in 1997?
Your answer should be compact. 0.98. What is the ratio of the Total Labor Force (in %) of Sri Lanka in 1995 to that in 1998?
Give a very brief answer. 0.94. What is the ratio of the Total Labor Force (in %) in Trinidad and Tobago in 1995 to that in 1998?
Make the answer very short. 0.98. What is the ratio of the Total Labor Force (in %) of Sri Lanka in 1995 to that in 1999?
Provide a short and direct response. 0.96. What is the ratio of the Total Labor Force (in %) in Trinidad and Tobago in 1995 to that in 1999?
Your response must be concise. 0.98. What is the ratio of the Total Labor Force (in %) in Least developed countries in 1995 to that in 2000?
Give a very brief answer. 1.01. What is the ratio of the Total Labor Force (in %) in Congo (Republic) in 1995 to that in 2000?
Make the answer very short. 0.98. What is the ratio of the Total Labor Force (in %) of Sri Lanka in 1995 to that in 2000?
Provide a succinct answer. 0.98. What is the ratio of the Total Labor Force (in %) of Trinidad and Tobago in 1995 to that in 2000?
Provide a succinct answer. 0.98. What is the ratio of the Total Labor Force (in %) of Least developed countries in 1996 to that in 1997?
Offer a terse response. 1. What is the ratio of the Total Labor Force (in %) in Congo (Republic) in 1996 to that in 1997?
Ensure brevity in your answer.  1. What is the ratio of the Total Labor Force (in %) in Sri Lanka in 1996 to that in 1997?
Make the answer very short. 1. What is the ratio of the Total Labor Force (in %) in Least developed countries in 1996 to that in 1998?
Offer a terse response. 1. What is the ratio of the Total Labor Force (in %) of Congo (Republic) in 1996 to that in 1998?
Give a very brief answer. 0.99. What is the ratio of the Total Labor Force (in %) of Sri Lanka in 1996 to that in 1998?
Ensure brevity in your answer.  0.94. What is the ratio of the Total Labor Force (in %) in Trinidad and Tobago in 1996 to that in 1998?
Offer a terse response. 0.99. What is the ratio of the Total Labor Force (in %) of Congo (Republic) in 1996 to that in 1999?
Make the answer very short. 0.99. What is the ratio of the Total Labor Force (in %) of Sri Lanka in 1996 to that in 1999?
Offer a terse response. 0.97. What is the ratio of the Total Labor Force (in %) of Congo (Republic) in 1996 to that in 2000?
Your answer should be compact. 0.99. What is the ratio of the Total Labor Force (in %) in Sri Lanka in 1996 to that in 2000?
Your answer should be very brief. 0.98. What is the ratio of the Total Labor Force (in %) of Least developed countries in 1997 to that in 1998?
Provide a succinct answer. 1. What is the ratio of the Total Labor Force (in %) of Congo (Republic) in 1997 to that in 1998?
Provide a succinct answer. 1. What is the ratio of the Total Labor Force (in %) of Sri Lanka in 1997 to that in 1998?
Give a very brief answer. 0.94. What is the ratio of the Total Labor Force (in %) of Sri Lanka in 1997 to that in 1999?
Offer a terse response. 0.97. What is the ratio of the Total Labor Force (in %) of Trinidad and Tobago in 1997 to that in 1999?
Provide a succinct answer. 1. What is the ratio of the Total Labor Force (in %) in Sri Lanka in 1997 to that in 2000?
Give a very brief answer. 0.98. What is the ratio of the Total Labor Force (in %) of Least developed countries in 1998 to that in 1999?
Offer a very short reply. 1. What is the ratio of the Total Labor Force (in %) in Sri Lanka in 1998 to that in 1999?
Your answer should be very brief. 1.03. What is the ratio of the Total Labor Force (in %) of Trinidad and Tobago in 1998 to that in 1999?
Ensure brevity in your answer.  1. What is the ratio of the Total Labor Force (in %) in Sri Lanka in 1998 to that in 2000?
Provide a succinct answer. 1.04. What is the ratio of the Total Labor Force (in %) in Trinidad and Tobago in 1998 to that in 2000?
Offer a terse response. 1. What is the ratio of the Total Labor Force (in %) of Least developed countries in 1999 to that in 2000?
Offer a very short reply. 1. What is the ratio of the Total Labor Force (in %) in Congo (Republic) in 1999 to that in 2000?
Provide a short and direct response. 1. What is the ratio of the Total Labor Force (in %) of Sri Lanka in 1999 to that in 2000?
Give a very brief answer. 1.01. What is the ratio of the Total Labor Force (in %) of Trinidad and Tobago in 1999 to that in 2000?
Give a very brief answer. 1. What is the difference between the highest and the second highest Total Labor Force (in %) in Least developed countries?
Provide a short and direct response. 0.08. What is the difference between the highest and the lowest Total Labor Force (in %) in Least developed countries?
Your answer should be very brief. 0.62. What is the difference between the highest and the lowest Total Labor Force (in %) in Congo (Republic)?
Your answer should be very brief. 1.6. What is the difference between the highest and the lowest Total Labor Force (in %) in Sri Lanka?
Keep it short and to the point. 4.1. 